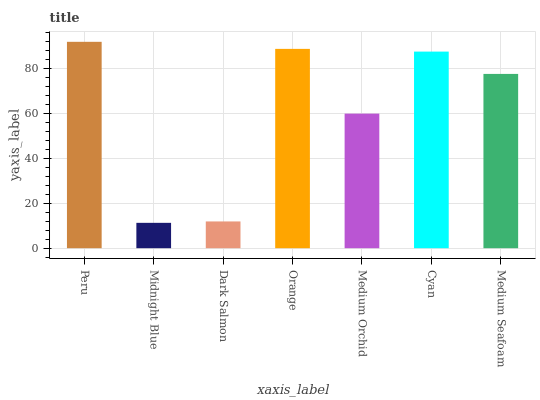Is Midnight Blue the minimum?
Answer yes or no. Yes. Is Peru the maximum?
Answer yes or no. Yes. Is Dark Salmon the minimum?
Answer yes or no. No. Is Dark Salmon the maximum?
Answer yes or no. No. Is Dark Salmon greater than Midnight Blue?
Answer yes or no. Yes. Is Midnight Blue less than Dark Salmon?
Answer yes or no. Yes. Is Midnight Blue greater than Dark Salmon?
Answer yes or no. No. Is Dark Salmon less than Midnight Blue?
Answer yes or no. No. Is Medium Seafoam the high median?
Answer yes or no. Yes. Is Medium Seafoam the low median?
Answer yes or no. Yes. Is Cyan the high median?
Answer yes or no. No. Is Orange the low median?
Answer yes or no. No. 